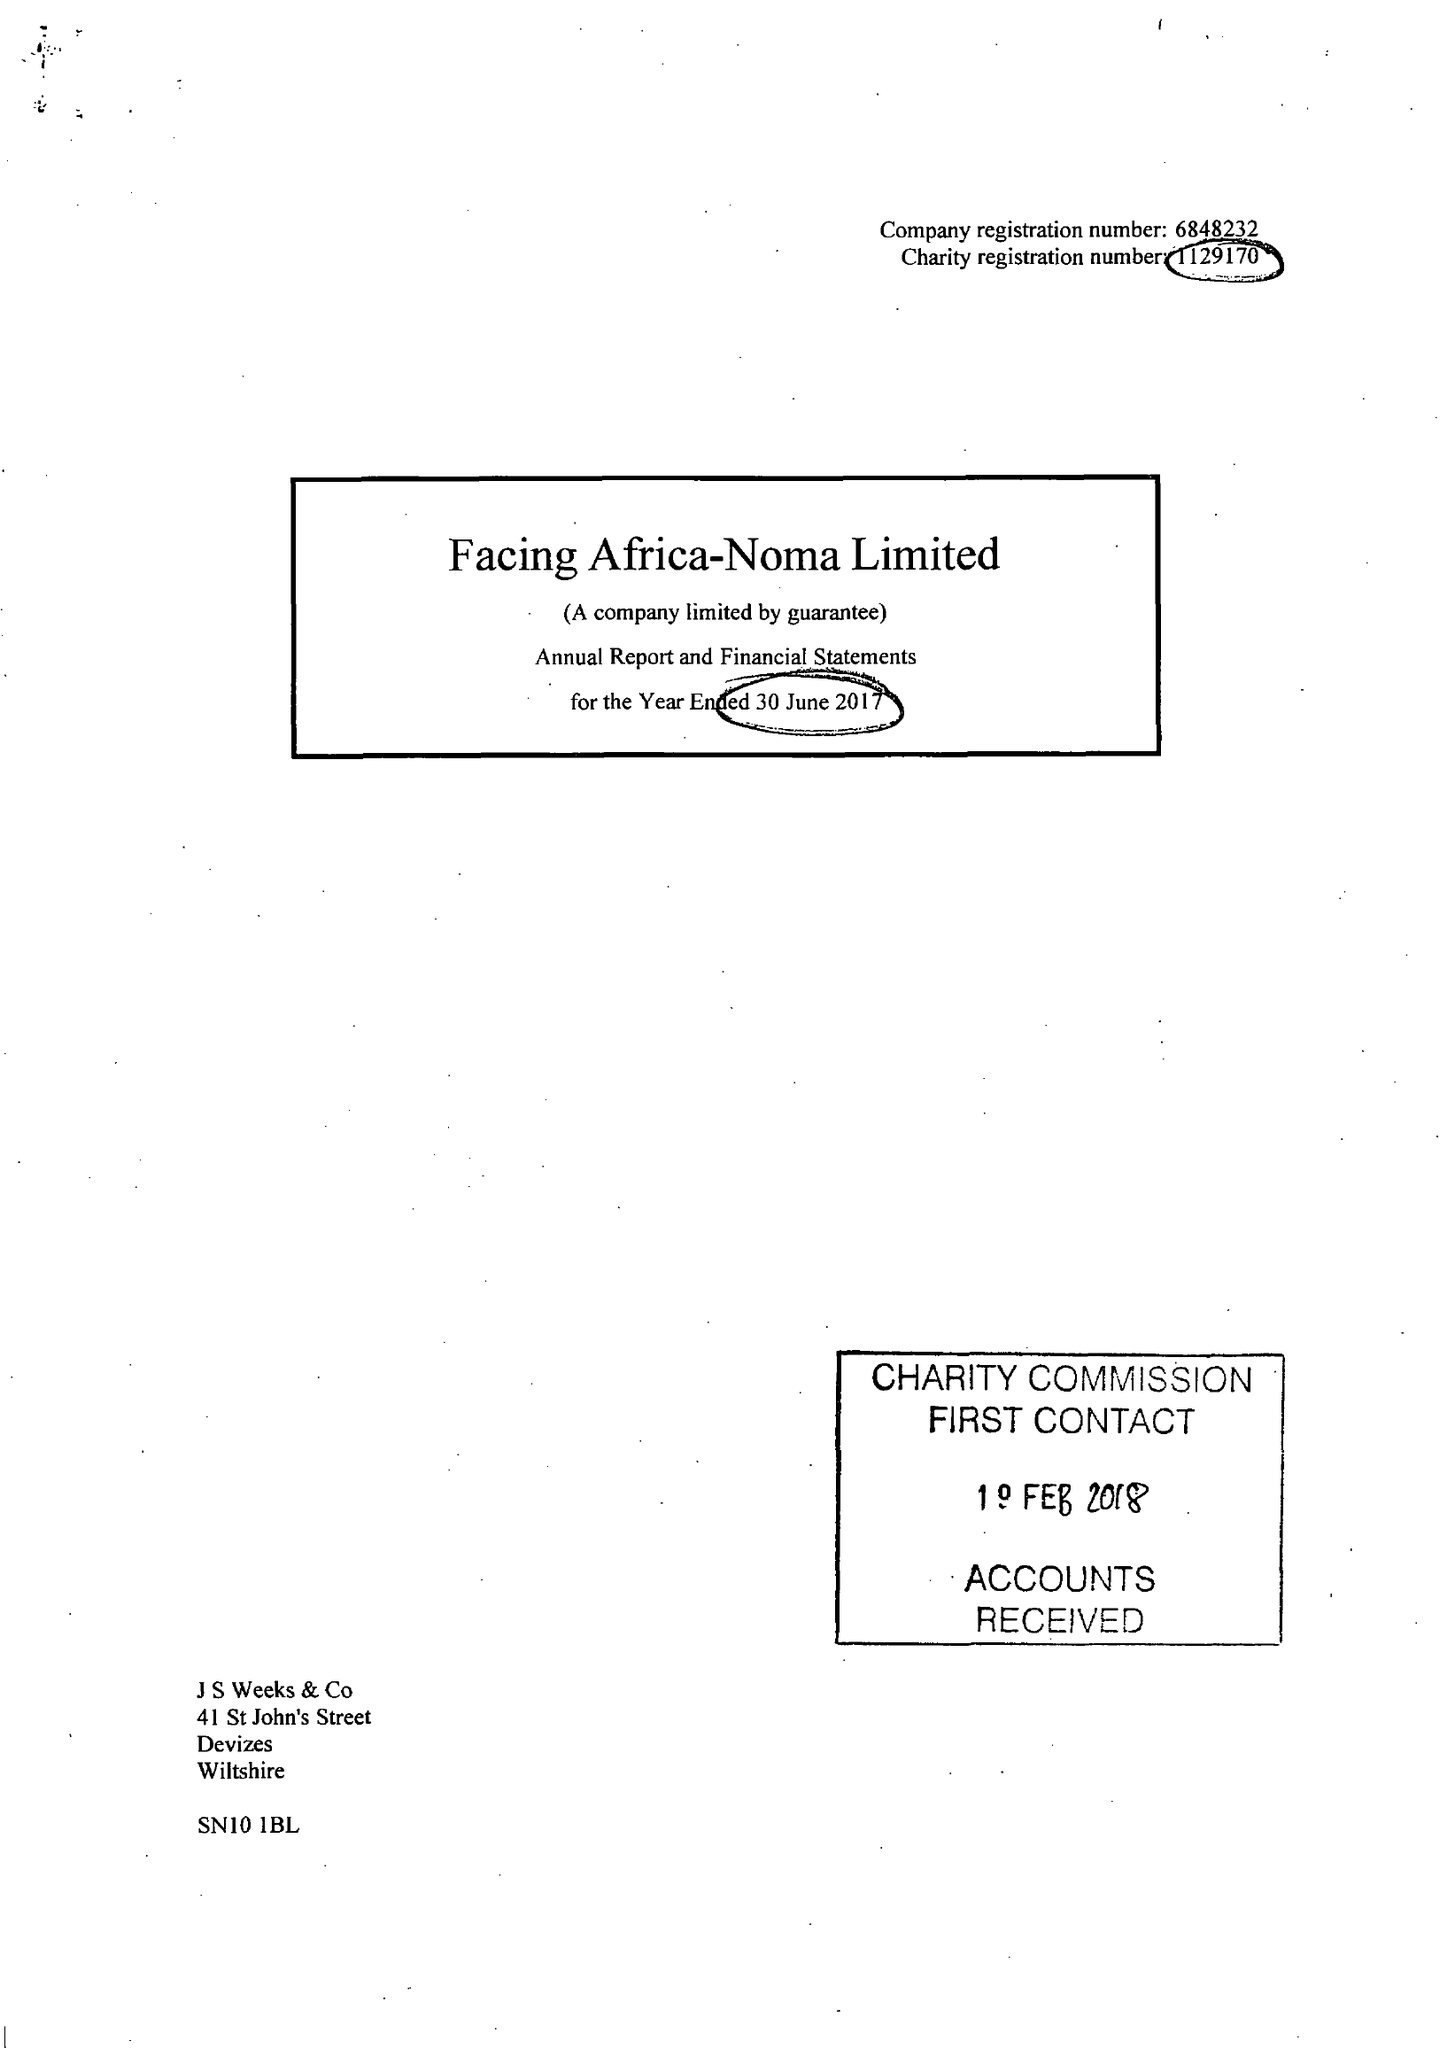What is the value for the address__postcode?
Answer the question using a single word or phrase. SN10 1DF 